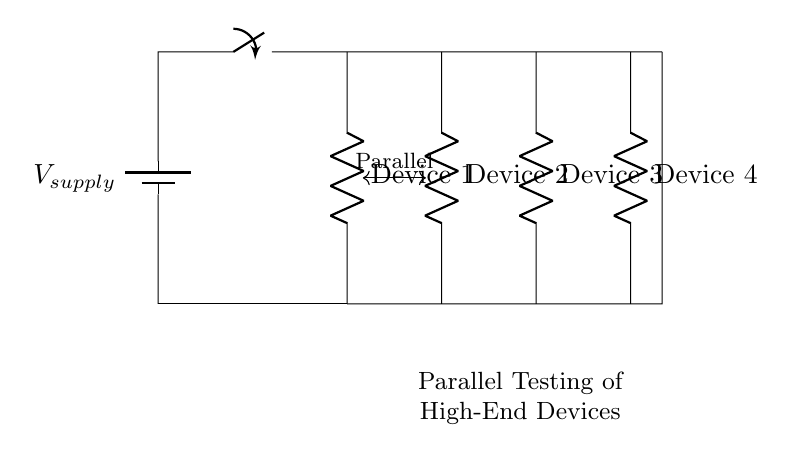What type of circuit is represented? The circuit is a parallel circuit, where multiple devices are connected across the same voltage source. Each component is connected in such a way that they share the same voltage while allowing independent operation.
Answer: Parallel circuit How many devices are connected in parallel? There are four devices connected in parallel, as indicated by the four resistors in the diagram, each labeled as Device 1, Device 2, Device 3, and Device 4.
Answer: Four devices What is the function of the switch in this circuit? The switch in the circuit serves to control the flow of electricity; when closed, it completes the circuit allowing current to flow to the connected devices. When open, it interrupts the current, effectively disconnecting the devices from the power source.
Answer: Control flow Are all devices receiving the same voltage? Yes, all devices are receiving the same voltage supplied by the power source, which is a characteristic of parallel circuits where the voltage across each branch remains constant at the supply voltage.
Answer: Yes If Device 1 has a resistance of 10 ohms, what is the total current flowing from the supply if the supply voltage is 20 volts? To find the total current, we first calculate the current through Device 1 using Ohm's law (I = V/R). The current through Device 1 is 20V / 10Ω = 2A. In a parallel circuit, the total current is the sum of the currents through each device, but we need the resistances of the other devices to calculate it fully. Assuming they are all the same as Device 1 for simplicity, then there would be 2A from each, leading to a total of 8A.
Answer: 8A What is the purpose of having a parallel circuit design for testing high-end devices? The purpose of a parallel circuit design is to allow multiple high-end devices to be tested simultaneously without affecting one another's performance. Each device operates independently at the same voltage, which provides an efficient testing environment and minimizes waiting time between tests.
Answer: Simultaneous testing 